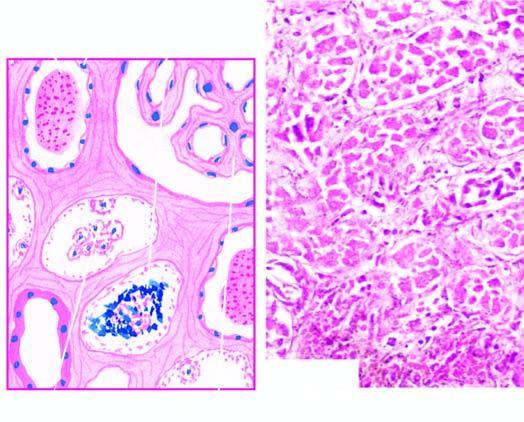s there extensive necrosis of epithelial cells involving predominantly proximal convoluted tubule diffusely?
Answer the question using a single word or phrase. Yes 